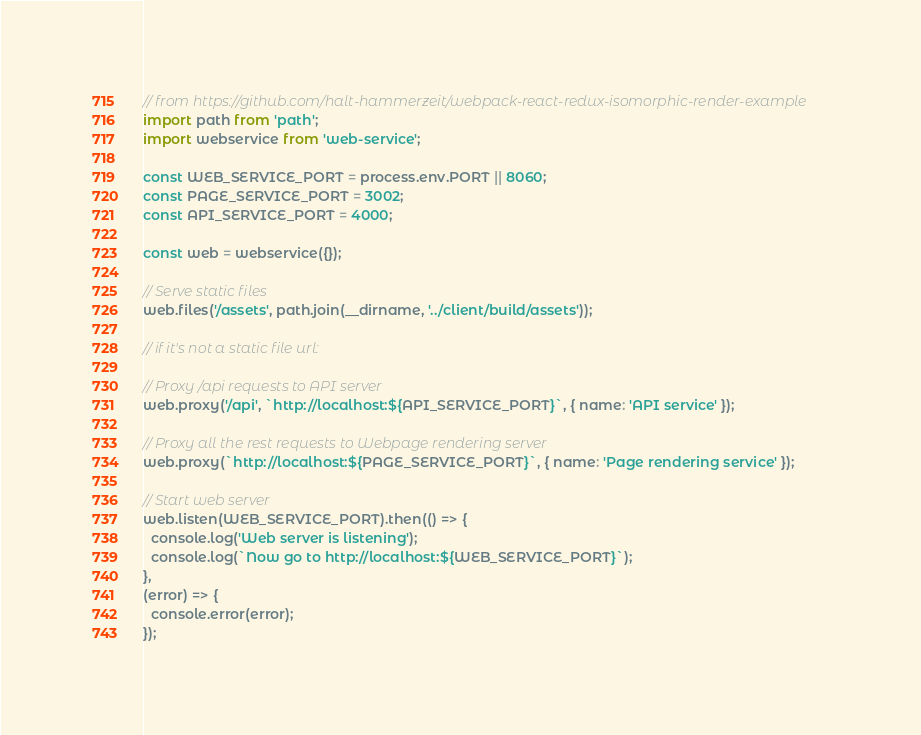Convert code to text. <code><loc_0><loc_0><loc_500><loc_500><_JavaScript_>// from https://github.com/halt-hammerzeit/webpack-react-redux-isomorphic-render-example
import path from 'path';
import webservice from 'web-service';

const WEB_SERVICE_PORT = process.env.PORT || 8060;
const PAGE_SERVICE_PORT = 3002;
const API_SERVICE_PORT = 4000;

const web = webservice({});

// Serve static files
web.files('/assets', path.join(__dirname, '../client/build/assets'));

// if it's not a static file url:

// Proxy /api requests to API server
web.proxy('/api', `http://localhost:${API_SERVICE_PORT}`, { name: 'API service' });

// Proxy all the rest requests to Webpage rendering server
web.proxy(`http://localhost:${PAGE_SERVICE_PORT}`, { name: 'Page rendering service' });

// Start web server
web.listen(WEB_SERVICE_PORT).then(() => {
  console.log('Web server is listening');
  console.log(`Now go to http://localhost:${WEB_SERVICE_PORT}`);
},
(error) => {
  console.error(error);
});
</code> 